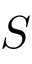Convert formula to latex. <formula><loc_0><loc_0><loc_500><loc_500>S</formula> 